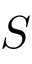Convert formula to latex. <formula><loc_0><loc_0><loc_500><loc_500>S</formula> 